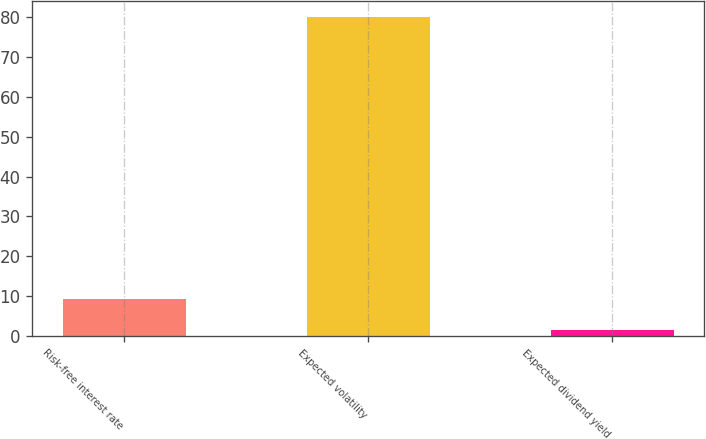Convert chart to OTSL. <chart><loc_0><loc_0><loc_500><loc_500><bar_chart><fcel>Risk-free interest rate<fcel>Expected volatility<fcel>Expected dividend yield<nl><fcel>9.24<fcel>80<fcel>1.38<nl></chart> 